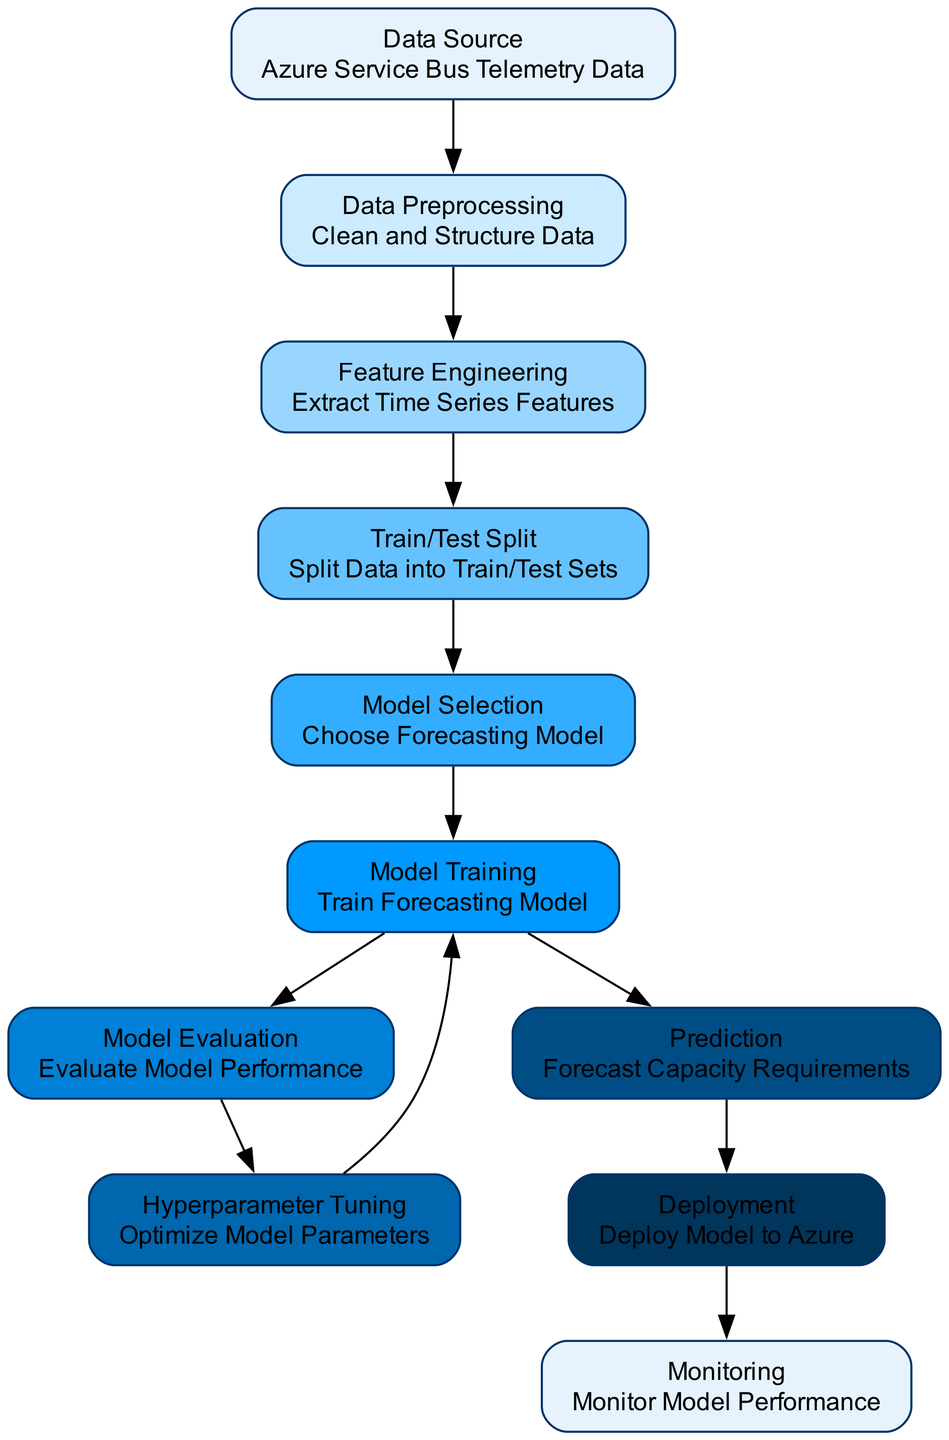What is the first step in the diagram? The first node in the diagram is "Data Source," which represents the starting point where Azure Service Bus Telemetry Data is obtained for further processing.
Answer: Data Source How many nodes are represented in this diagram? By counting all the individual nodes shown in the diagram, we see there are 11 distinct nodes involved in the Azure Service Bus capacity forecasting process.
Answer: 11 What comes after model evaluation in the workflow? According to the directed flow in the diagram, after "Model Evaluation," the next step is "Hyperparameter Tuning," which focuses on optimizing the model parameters before retraining.
Answer: Hyperparameter Tuning Which node is related to the deployment of the model? The node labeled "Deployment" is directly linked to the "Prediction" node, as it signifies where the forecasting model is deployed into Azure after predictions have been made.
Answer: Deployment Where do the data preprocessing activities originate from? The "Data Preprocessing" node in the diagram receives its data directly from the "Data Source" node, indicating that the telemetry data needs to be cleaned and structured right after it is sourced.
Answer: Data Source What process is performed immediately before making predictions? The last step conducted just prior to making predictions is "Model Training," where the selected model is trained using the processed data to generate accurate forecasts based on the features extracted.
Answer: Model Training What type of data does the overarching process deal with? The overarching process illustrated in the diagram specifically deals with Azure Service Bus Telemetry Data, as indicated in the first node "Data Source."
Answer: Azure Service Bus Telemetry Data After deployment, what should be monitored? Once the model is deployed, the next step involves "Monitoring," which includes overseeing the model's performance to ensure it meets the forecasting requirements effectively.
Answer: Monitoring Which node undergoes iterations through hyperparameter tuning? The "Model Training" node is the one that undergoes iterations as part of the hyperparameter tuning process, where various model parameters are optimized to enhance performance before final training.
Answer: Model Training 